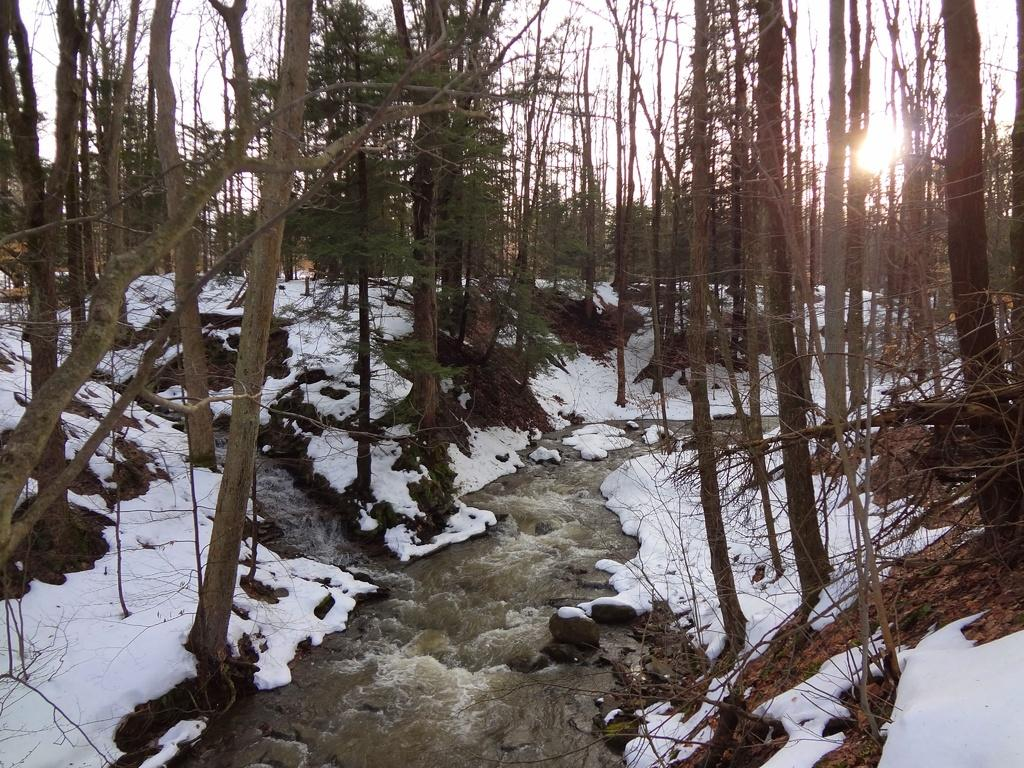What is happening in the image? There is water flowing in the image. What type of vegetation can be seen in the image? There are trees in the image. What is visible at the top of the image? The sky is visible at the top of the image. What type of quince is being used to form the trees in the image? There is no quince present in the image, and the trees are not formed using any type of quince. 